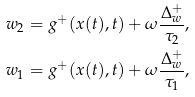Convert formula to latex. <formula><loc_0><loc_0><loc_500><loc_500>w _ { 2 } = g ^ { + } ( x ( t ) , t ) + \omega \frac { \Delta ^ { + } _ { w } } { \tau _ { 2 } } , \\ w _ { 1 } = g ^ { + } ( x ( t ) , t ) + \omega \frac { \Delta ^ { + } _ { w } } { \tau _ { 1 } } ,</formula> 